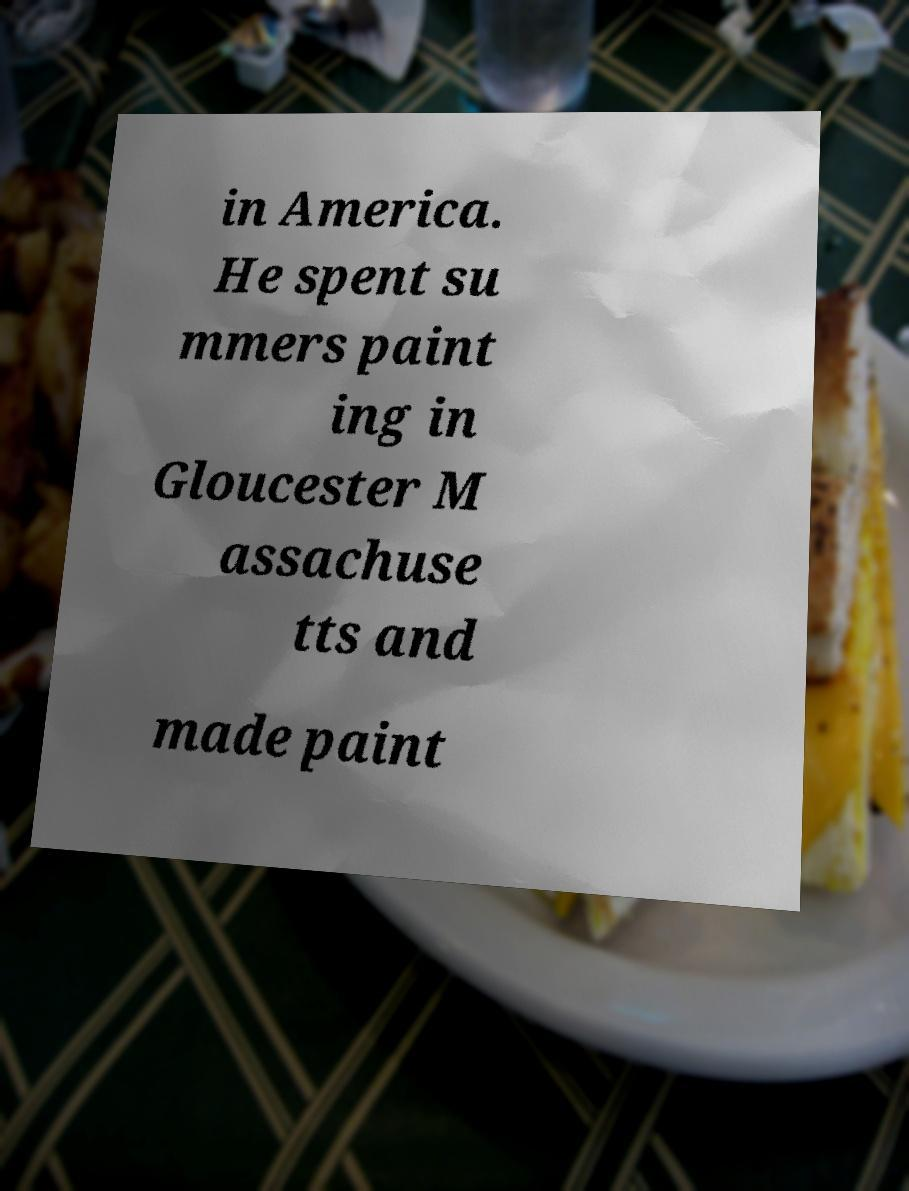I need the written content from this picture converted into text. Can you do that? in America. He spent su mmers paint ing in Gloucester M assachuse tts and made paint 